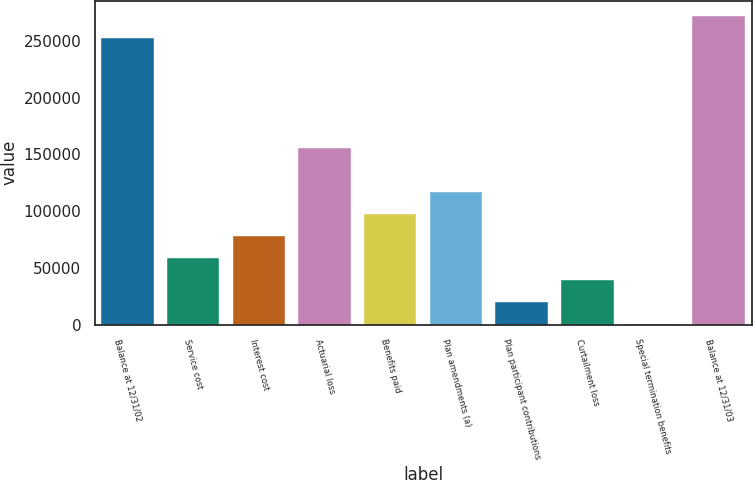Convert chart. <chart><loc_0><loc_0><loc_500><loc_500><bar_chart><fcel>Balance at 12/31/02<fcel>Service cost<fcel>Interest cost<fcel>Actuarial loss<fcel>Benefits paid<fcel>Plan amendments (a)<fcel>Plan participant contributions<fcel>Curtailment loss<fcel>Special termination benefits<fcel>Balance at 12/31/03<nl><fcel>252313<fcel>58619.9<fcel>77989.2<fcel>155466<fcel>97358.5<fcel>116728<fcel>19881.3<fcel>39250.6<fcel>512<fcel>271682<nl></chart> 